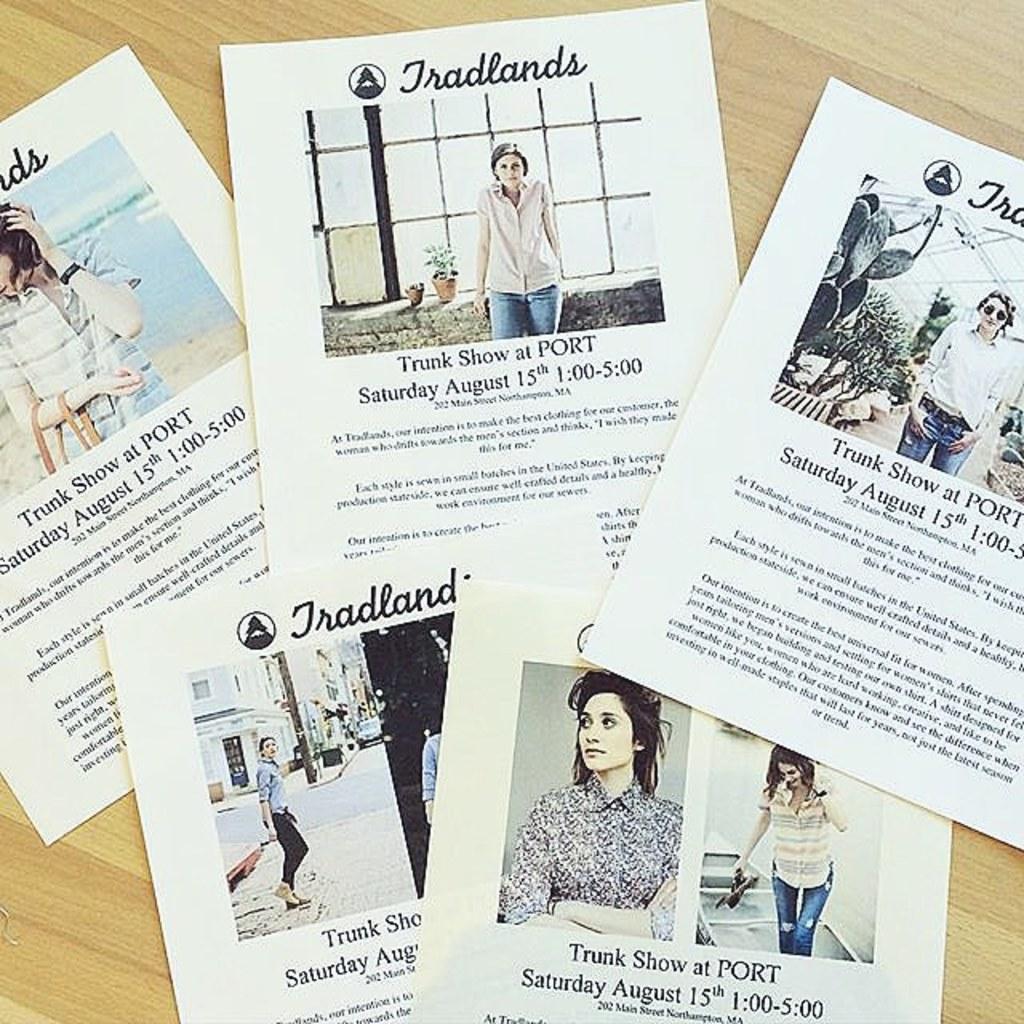In one or two sentences, can you explain what this image depicts? The picture consists of pamphlets on a wooden surface. In the pamphlets we can see women and text. 